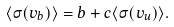Convert formula to latex. <formula><loc_0><loc_0><loc_500><loc_500>\langle \sigma ( v _ { b } ) \rangle = b + c \langle \sigma ( v _ { u } ) \rangle .</formula> 